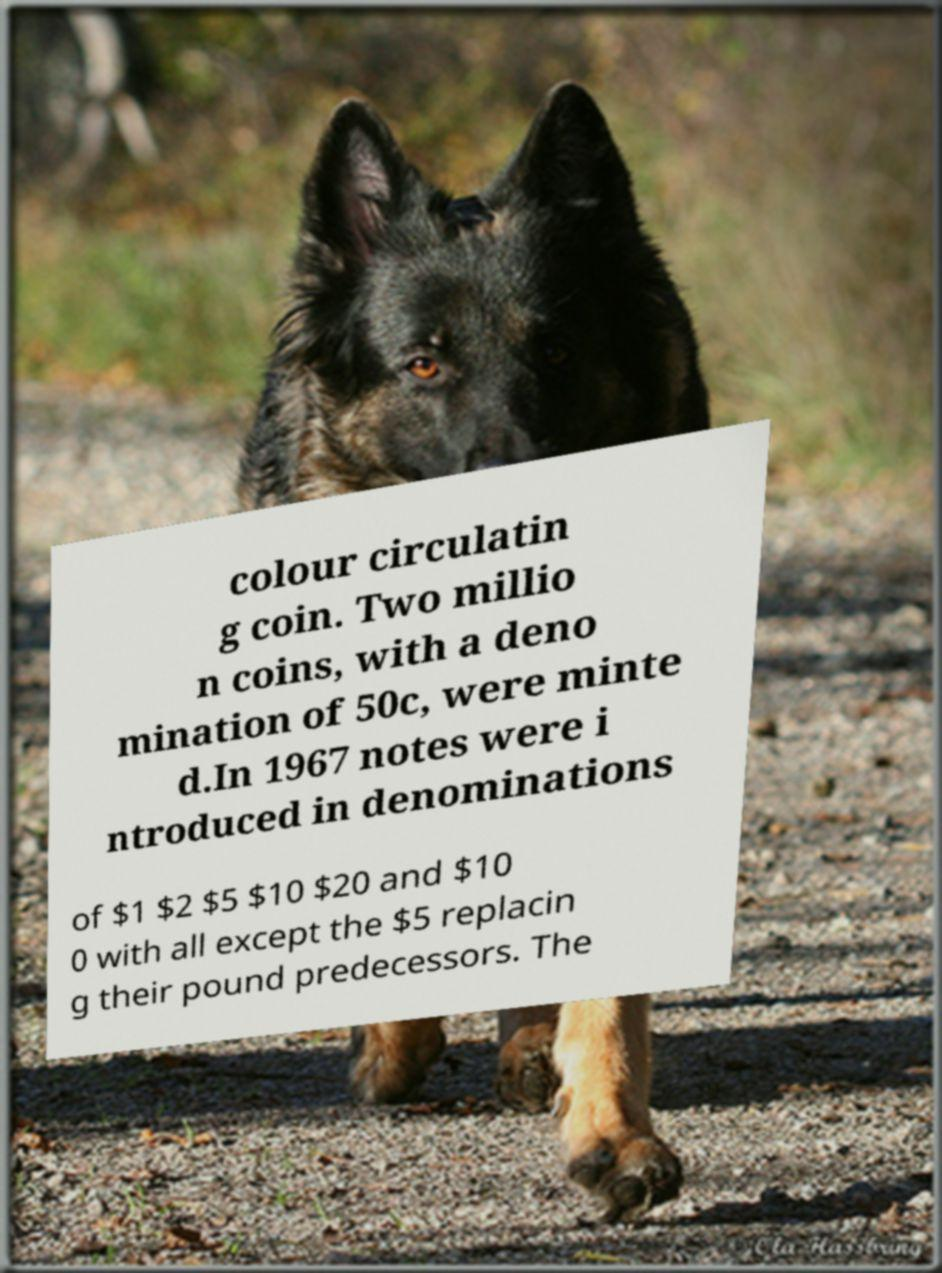Please read and relay the text visible in this image. What does it say? The text in the image provides historical information about currency changes, mentioning the introduction of color circulating coins in 1967 with a denomination of 50c. Additionally, notes were introduced in denominations of $1, $2, $5, $10, $20, and $100, replacing most pound predecessors except for the $5 note. 